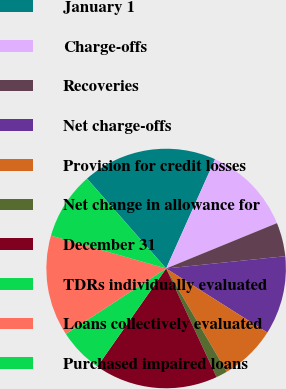Convert chart to OTSL. <chart><loc_0><loc_0><loc_500><loc_500><pie_chart><fcel>January 1<fcel>Charge-offs<fcel>Recoveries<fcel>Net charge-offs<fcel>Provision for credit losses<fcel>Net change in allowance for<fcel>December 31<fcel>TDRs individually evaluated<fcel>Loans collectively evaluated<fcel>Purchased impaired loans<nl><fcel>18.18%<fcel>12.12%<fcel>4.55%<fcel>10.61%<fcel>7.58%<fcel>1.52%<fcel>16.66%<fcel>6.06%<fcel>13.63%<fcel>9.09%<nl></chart> 